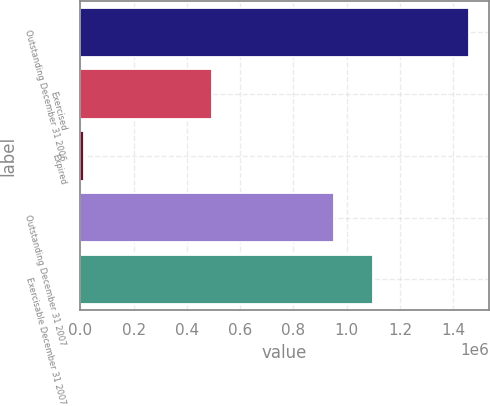Convert chart. <chart><loc_0><loc_0><loc_500><loc_500><bar_chart><fcel>Outstanding December 31 2006<fcel>Exercised<fcel>Expired<fcel>Outstanding December 31 2007<fcel>Exercisable December 31 2007<nl><fcel>1.46067e+06<fcel>494229<fcel>13293<fcel>953146<fcel>1.09788e+06<nl></chart> 